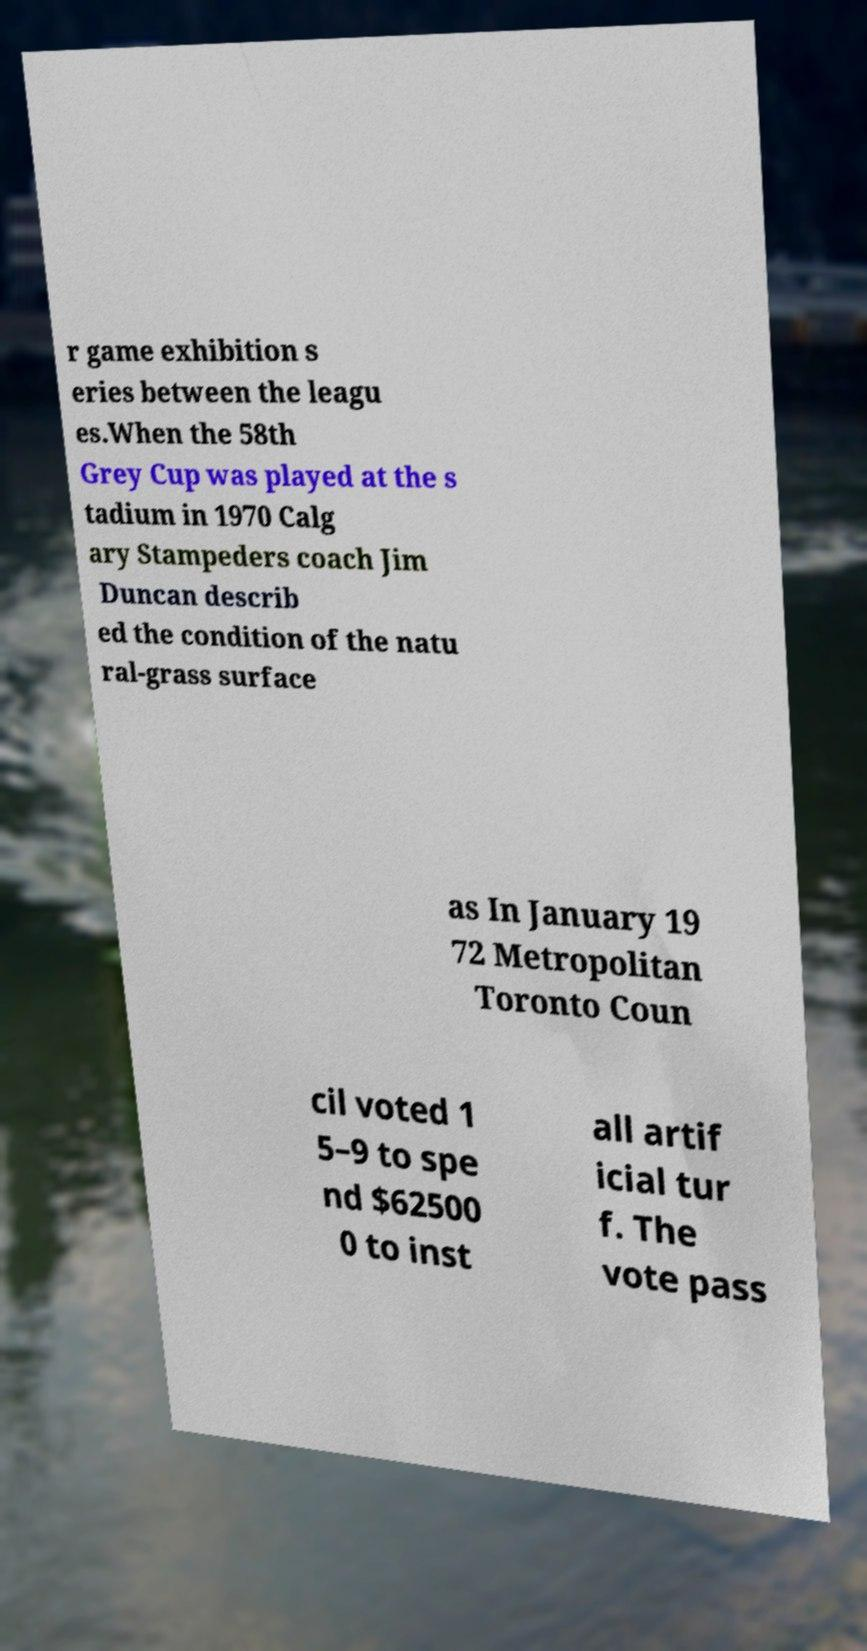Could you extract and type out the text from this image? r game exhibition s eries between the leagu es.When the 58th Grey Cup was played at the s tadium in 1970 Calg ary Stampeders coach Jim Duncan describ ed the condition of the natu ral-grass surface as In January 19 72 Metropolitan Toronto Coun cil voted 1 5–9 to spe nd $62500 0 to inst all artif icial tur f. The vote pass 